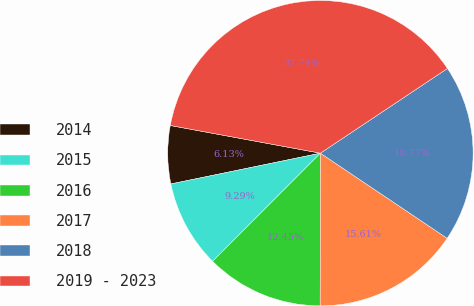<chart> <loc_0><loc_0><loc_500><loc_500><pie_chart><fcel>2014<fcel>2015<fcel>2016<fcel>2017<fcel>2018<fcel>2019 - 2023<nl><fcel>6.13%<fcel>9.29%<fcel>12.45%<fcel>15.61%<fcel>18.77%<fcel>37.73%<nl></chart> 